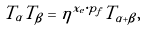<formula> <loc_0><loc_0><loc_500><loc_500>T _ { \alpha } T _ { \beta } = \eta ^ { x _ { e } \cdot p _ { f } } T _ { \alpha + \beta } ,</formula> 